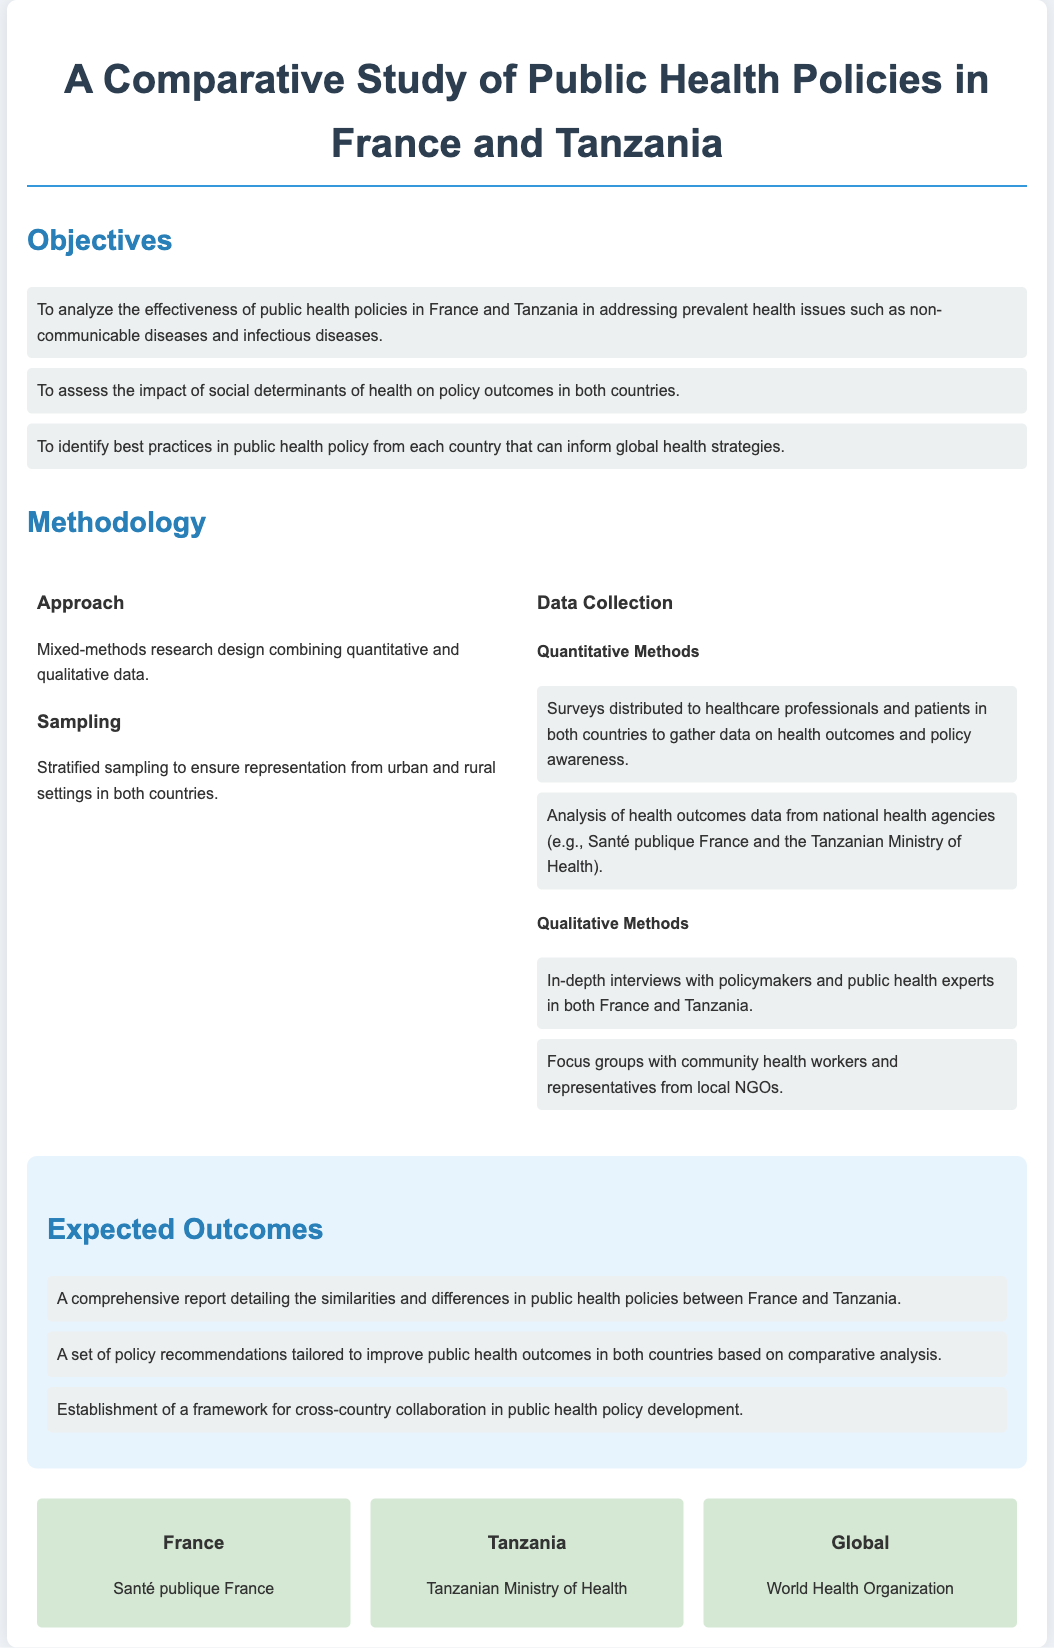What are the three main objectives of the study? The objectives listed in the document provide specific aims for the research, treating them as distinct goals.
Answer: To analyze the effectiveness, assess the impact, identify best practices What research design is being used in the study? The document specifies the research design as a mixed-methods approach, combining different types of data collection.
Answer: Mixed-methods research design What type of data collection method involves surveys? The document categorizes quantitative methods including surveys for data collection.
Answer: Quantitative Methods Which organization in France is mentioned for health data analysis? The document refers to a specific French organization involved in health statistics.
Answer: Santé publique France What framework is expected to be established as an outcome of the study? The expected outcomes mention collaborative efforts in public health policy.
Answer: A framework for cross-country collaboration What is one qualitative method used in the research? The document highlights in-depth interviews as a form of qualitative methodology for gathering insights.
Answer: In-depth interviews What health issues are being addressed in the study? The objectives outline specific health challenges that the study aims to analyze.
Answer: Non-communicable diseases and infectious diseases Who is the relevant entity for Tanzania mentioned in the document? The specific organization in Tanzania responsible for health policies is indicated.
Answer: Tanzanian Ministry of Health What are the expected outcomes of the research? The document summarizes different anticipated results from the comparative study.
Answer: Comprehensive report, policy recommendations, collaboration framework 